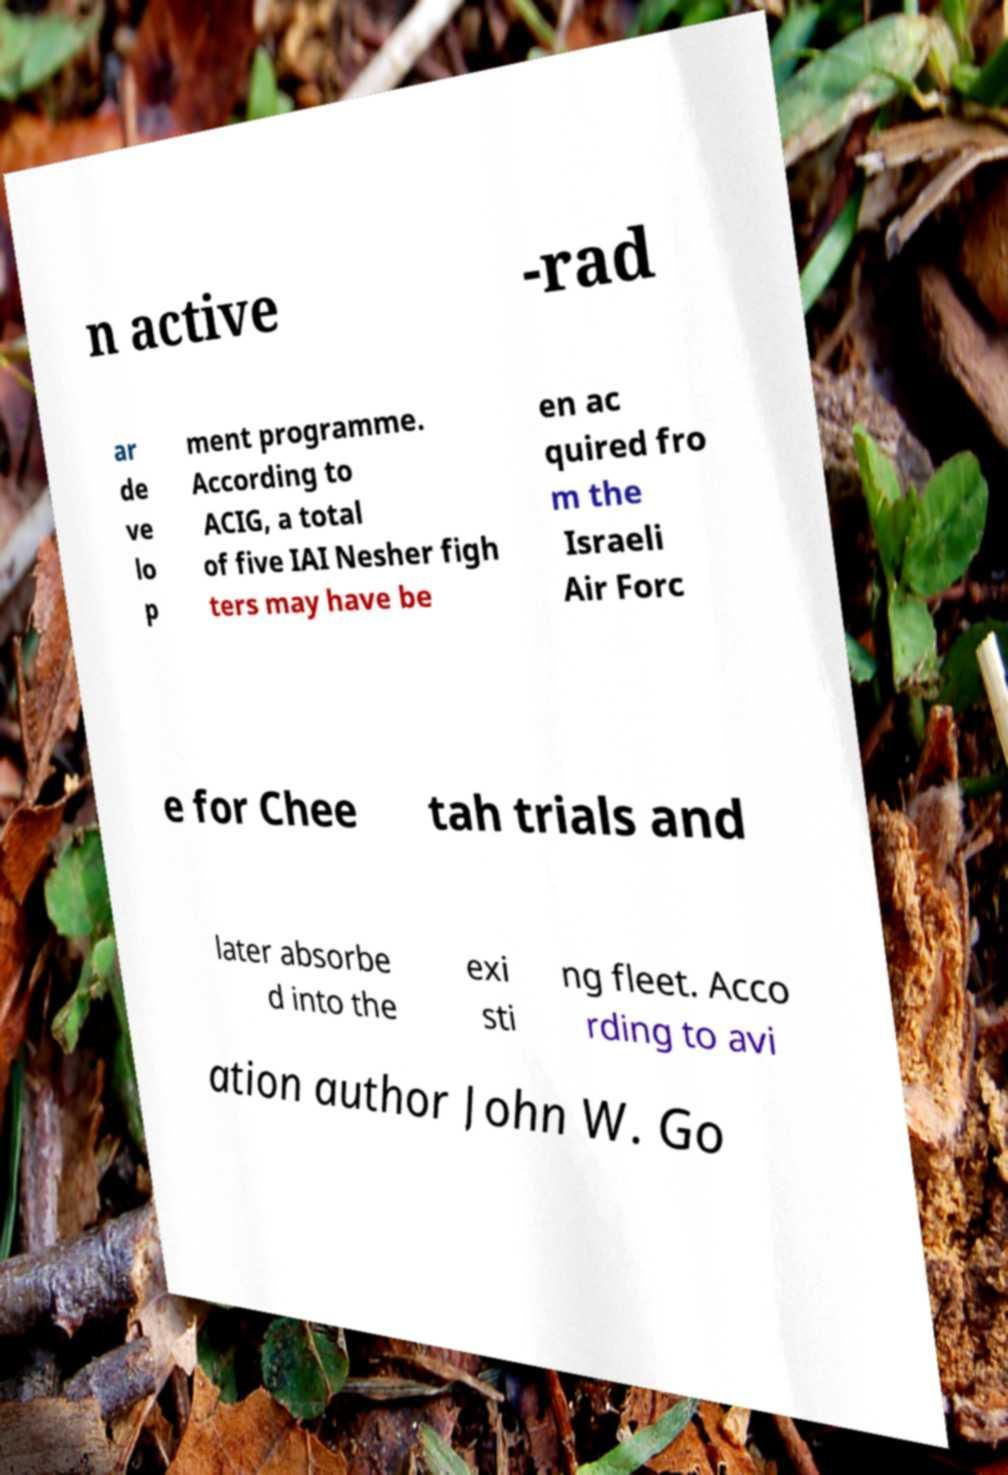What messages or text are displayed in this image? I need them in a readable, typed format. n active -rad ar de ve lo p ment programme. According to ACIG, a total of five IAI Nesher figh ters may have be en ac quired fro m the Israeli Air Forc e for Chee tah trials and later absorbe d into the exi sti ng fleet. Acco rding to avi ation author John W. Go 